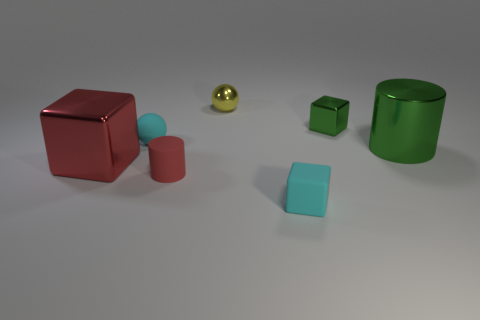There is a tiny shiny thing that is the same shape as the large red thing; what color is it?
Your answer should be compact. Green. Is there anything else that has the same color as the matte cube?
Give a very brief answer. Yes. Is the size of the cube that is on the left side of the tiny cyan rubber block the same as the metal block that is behind the tiny rubber sphere?
Make the answer very short. No. Are there the same number of things behind the small cyan rubber block and small cyan blocks that are behind the green metallic block?
Give a very brief answer. No. Is the size of the red shiny cube the same as the green metal cube behind the cyan block?
Offer a terse response. No. There is a cylinder behind the red cube; are there any small matte blocks that are behind it?
Offer a very short reply. No. Are there any red metallic things of the same shape as the yellow thing?
Keep it short and to the point. No. What number of yellow balls are left of the small cyan rubber thing that is left of the tiny cube that is in front of the rubber ball?
Offer a very short reply. 0. Do the rubber cube and the tiny matte object behind the red cube have the same color?
Ensure brevity in your answer.  Yes. How many objects are either cyan objects that are behind the large metallic cylinder or things that are left of the tiny cyan rubber cube?
Provide a short and direct response. 4. 